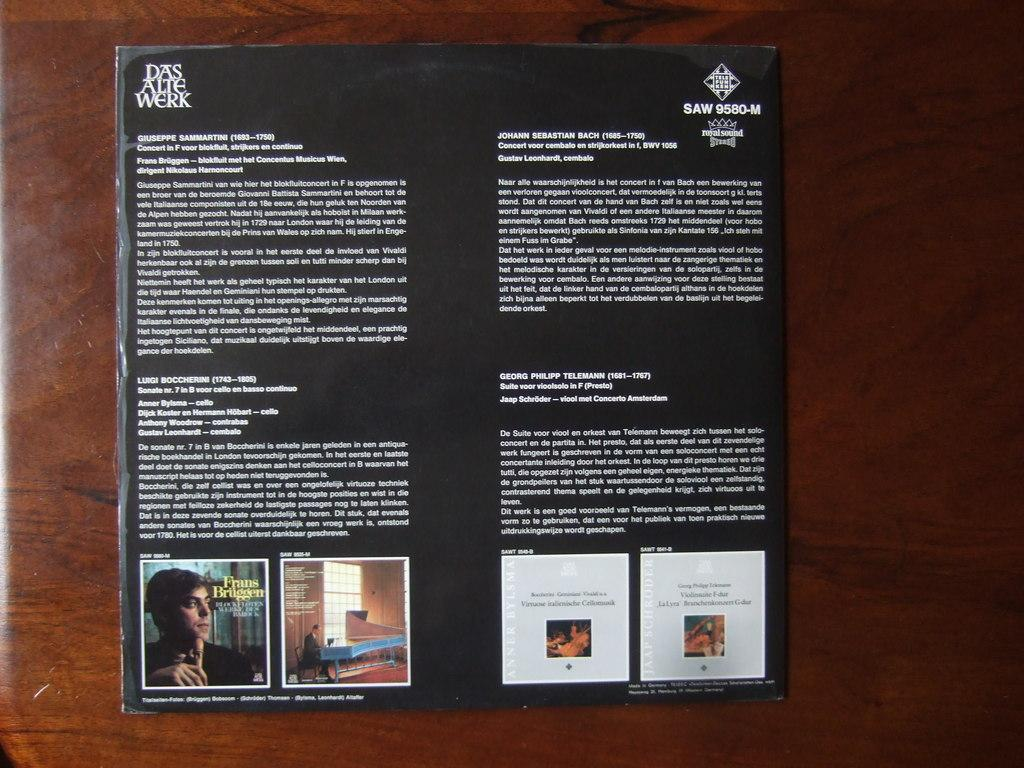What is the color of the surface in the image? The surface in the image is brown colored. What is placed on the surface? There is a black colored paper on the surface. What can be found on the black paper? Words are written on the paper, and there are images of a person. What type of cushion is being used to support the meal in the image? There is no cushion or meal present in the image; it only contains a brown surface with a black paper on it. 